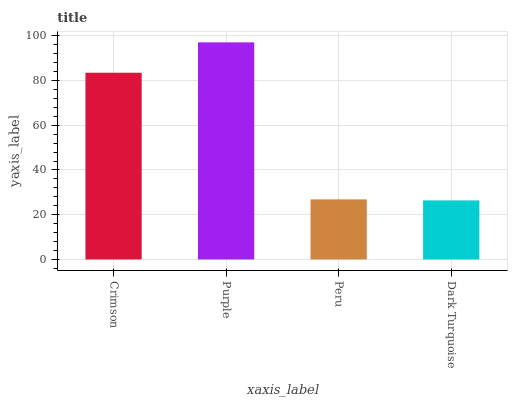Is Peru the minimum?
Answer yes or no. No. Is Peru the maximum?
Answer yes or no. No. Is Purple greater than Peru?
Answer yes or no. Yes. Is Peru less than Purple?
Answer yes or no. Yes. Is Peru greater than Purple?
Answer yes or no. No. Is Purple less than Peru?
Answer yes or no. No. Is Crimson the high median?
Answer yes or no. Yes. Is Peru the low median?
Answer yes or no. Yes. Is Dark Turquoise the high median?
Answer yes or no. No. Is Dark Turquoise the low median?
Answer yes or no. No. 